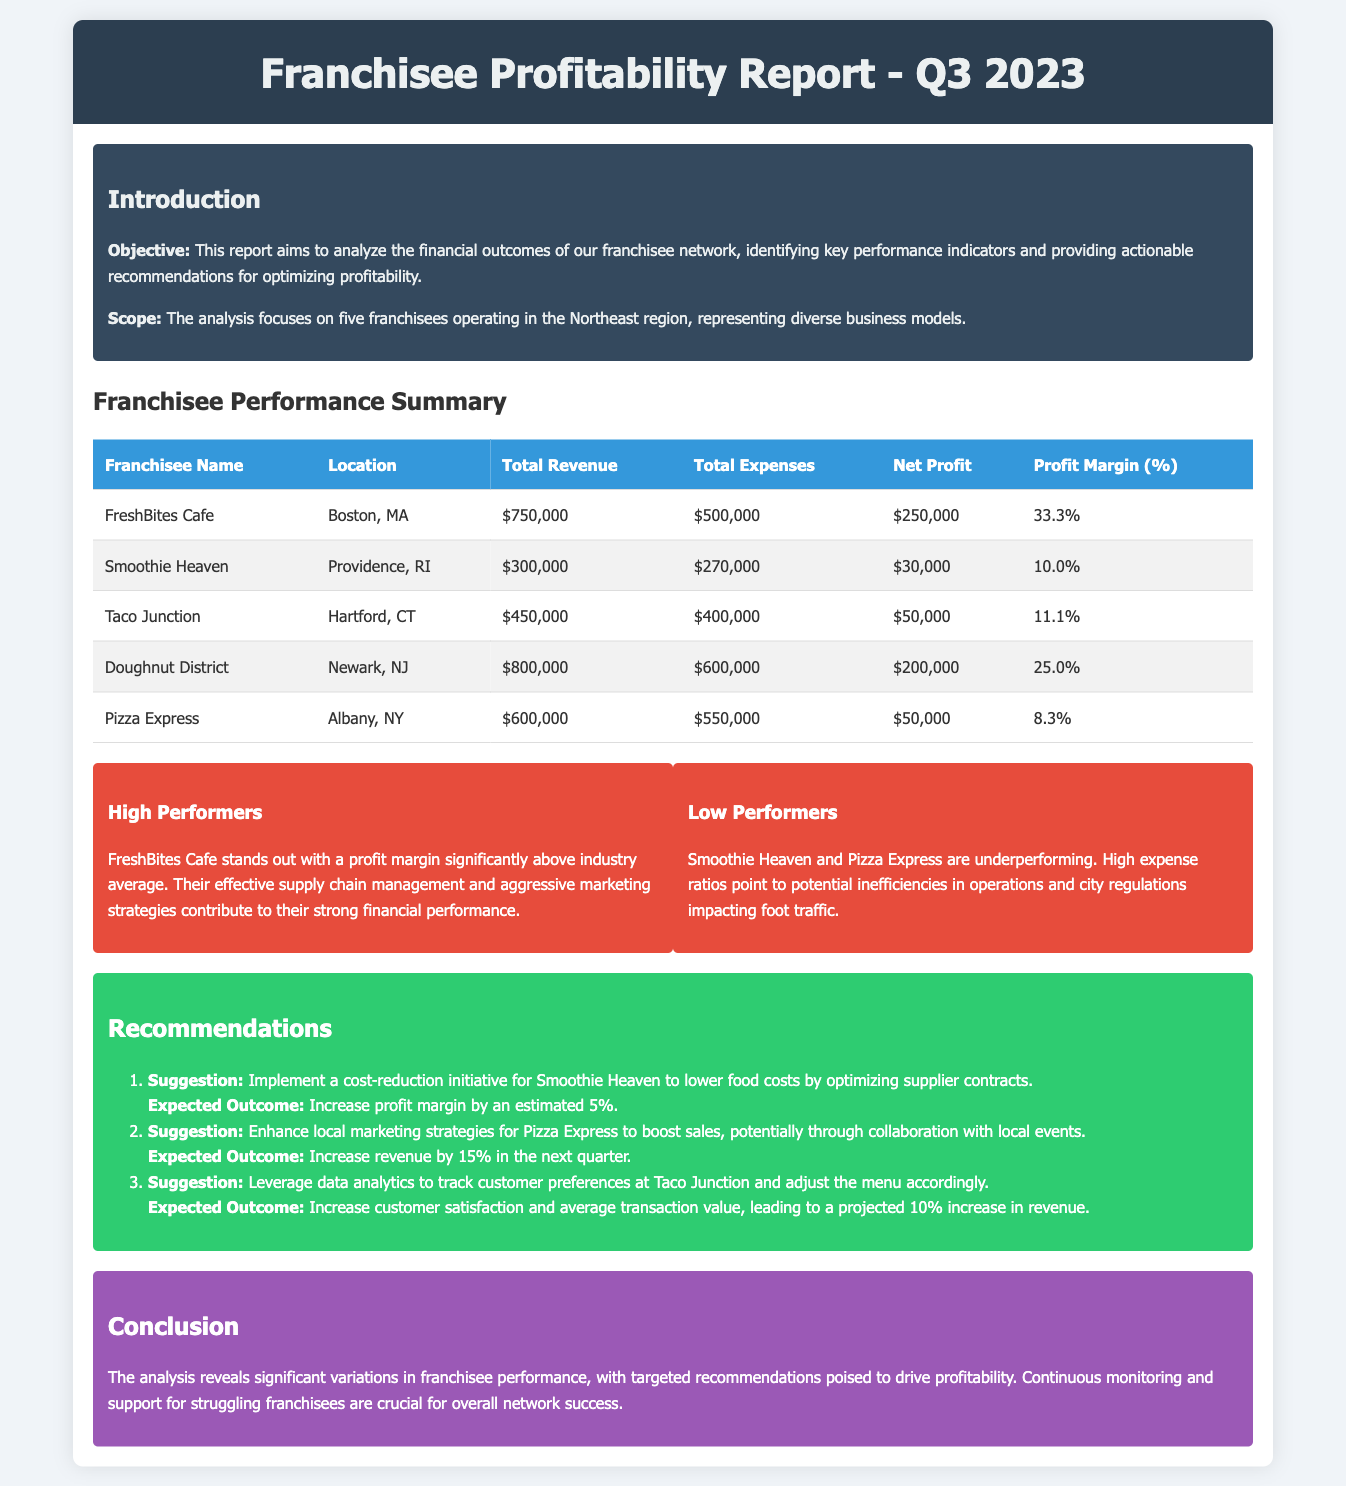What is the total revenue for FreshBites Cafe? The total revenue for FreshBites Cafe is specified in the document, which is $750,000.
Answer: $750,000 What is the profit margin for Doughnut District? The profit margin for Doughnut District is listed in the table as 25.0%.
Answer: 25.0% Which franchisee has the lowest net profit? By analyzing the net profit values, Smoothie Heaven is identified as having the lowest net profit of $30,000.
Answer: $30,000 What recommendation is made for Smoothie Heaven? The document suggests implementing a cost-reduction initiative for Smoothie Heaven to lower food costs.
Answer: Cost-reduction initiative How much is the expected revenue increase for Pizza Express? The expected outcome for enhancing local marketing strategies for Pizza Express is an increase in revenue by 15%.
Answer: 15% Which franchisee stands out as a high performer? The document identifies FreshBites Cafe as the high performer based on its profit margin.
Answer: FreshBites Cafe What is the total expenses value for Taco Junction? The document indicates that the total expenses for Taco Junction amount to $400,000.
Answer: $400,000 What is the conclusion of the report? The conclusion emphasizes that significant variations in franchisee performance have been revealed, necessitating targeted recommendations.
Answer: Targeted recommendations What recommendation is made regarding Taco Junction? The document recommends leveraging data analytics to track customer preferences at Taco Junction.
Answer: Data analytics for customer preferences 